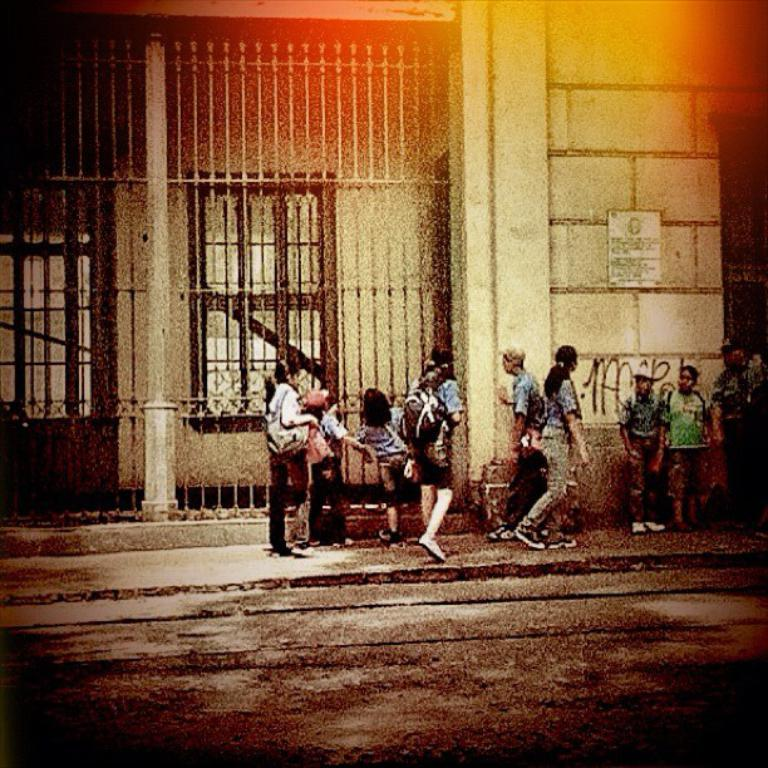What type of structure is present in the image? There is a building in the image. What feature can be observed on the building? The building has windows. Who or what else is present in the image? There are people in the image. Can you describe the appearance of the people in the image? The people are wearing different color dresses. What type of net can be seen in the image? There is no net present in the image. Can you describe the pickle that is being held by one of the people in the image? There is no pickle present in the image. 